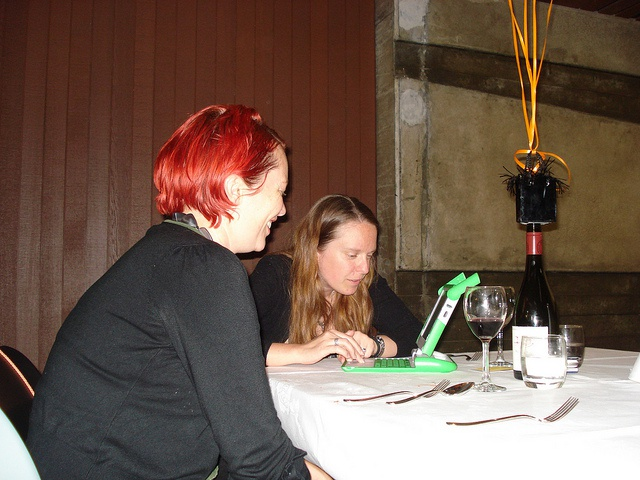Describe the objects in this image and their specific colors. I can see people in black, gray, purple, and maroon tones, dining table in black, white, darkgray, and lightgray tones, people in black, tan, gray, and maroon tones, laptop in black, ivory, lightgreen, and green tones, and bottle in black, white, brown, and maroon tones in this image. 